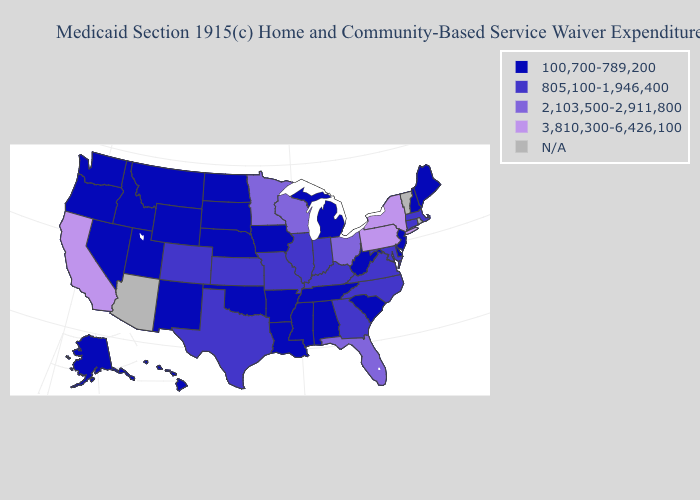What is the value of Massachusetts?
Write a very short answer. 805,100-1,946,400. Name the states that have a value in the range N/A?
Be succinct. Arizona, Rhode Island, Vermont. Does California have the highest value in the USA?
Give a very brief answer. Yes. What is the highest value in states that border North Dakota?
Be succinct. 2,103,500-2,911,800. What is the value of Idaho?
Write a very short answer. 100,700-789,200. Name the states that have a value in the range 100,700-789,200?
Give a very brief answer. Alabama, Alaska, Arkansas, Delaware, Hawaii, Idaho, Iowa, Louisiana, Maine, Michigan, Mississippi, Montana, Nebraska, Nevada, New Hampshire, New Jersey, New Mexico, North Dakota, Oklahoma, Oregon, South Carolina, South Dakota, Tennessee, Utah, Washington, West Virginia, Wyoming. Among the states that border Florida , does Georgia have the lowest value?
Give a very brief answer. No. Name the states that have a value in the range 805,100-1,946,400?
Keep it brief. Colorado, Connecticut, Georgia, Illinois, Indiana, Kansas, Kentucky, Maryland, Massachusetts, Missouri, North Carolina, Texas, Virginia. What is the value of North Dakota?
Quick response, please. 100,700-789,200. Name the states that have a value in the range N/A?
Give a very brief answer. Arizona, Rhode Island, Vermont. Which states hav the highest value in the South?
Short answer required. Florida. Name the states that have a value in the range 3,810,300-6,426,100?
Short answer required. California, New York, Pennsylvania. Which states have the highest value in the USA?
Give a very brief answer. California, New York, Pennsylvania. What is the highest value in the West ?
Keep it brief. 3,810,300-6,426,100. 